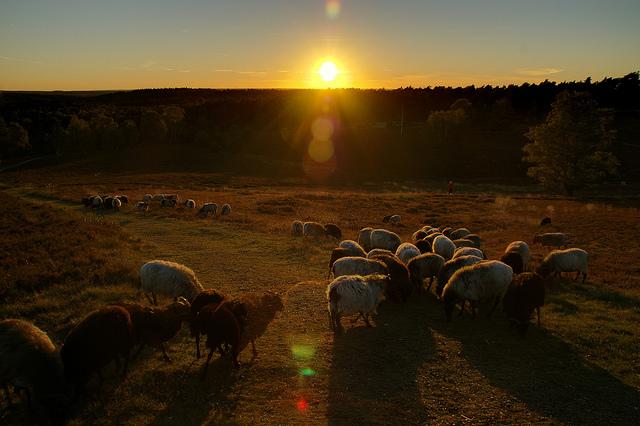Does this scene take place in a tropical climate?
Answer briefly. No. Is the sun setting?
Be succinct. Yes. What color is the sky?
Be succinct. Blue. What kind of animal is pictured?
Keep it brief. Sheep. Are there any people visible in this picture?
Answer briefly. No. What are the animals standing in?
Write a very short answer. Field. How many lamb are there in the picture?
Short answer required. Many. 